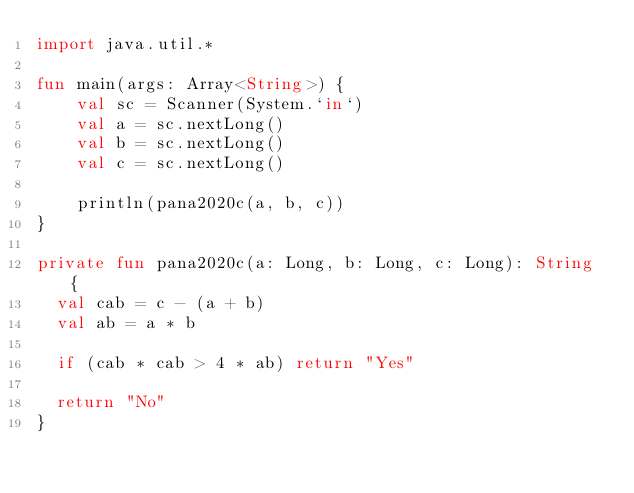<code> <loc_0><loc_0><loc_500><loc_500><_Kotlin_>import java.util.*

fun main(args: Array<String>) {
    val sc = Scanner(System.`in`)
    val a = sc.nextLong()
    val b = sc.nextLong()
    val c = sc.nextLong()

    println(pana2020c(a, b, c))
}

private fun pana2020c(a: Long, b: Long, c: Long): String {
  val cab = c - (a + b)
  val ab = a * b

  if (cab * cab > 4 * ab) return "Yes"

  return "No"
}</code> 